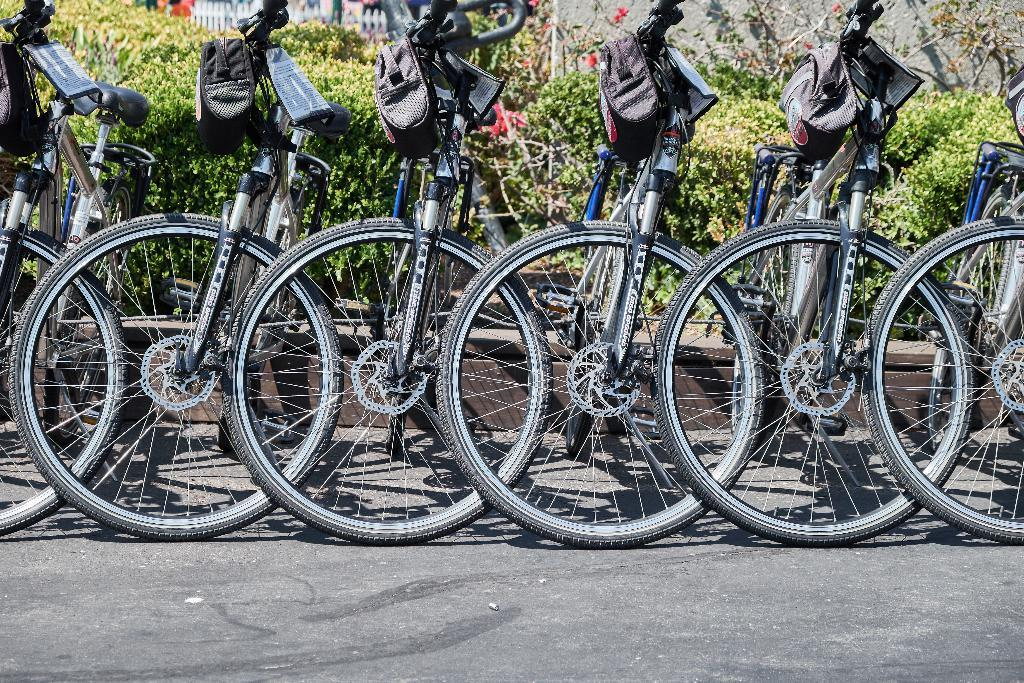What can be seen parked in the image? There are bicycles parked in the image. What is visible in the background of the image? There are plants in the background of the image. Can you see a girl playing basketball with a hose in the image? No, there is no girl, basketball, or hose present in the image. 